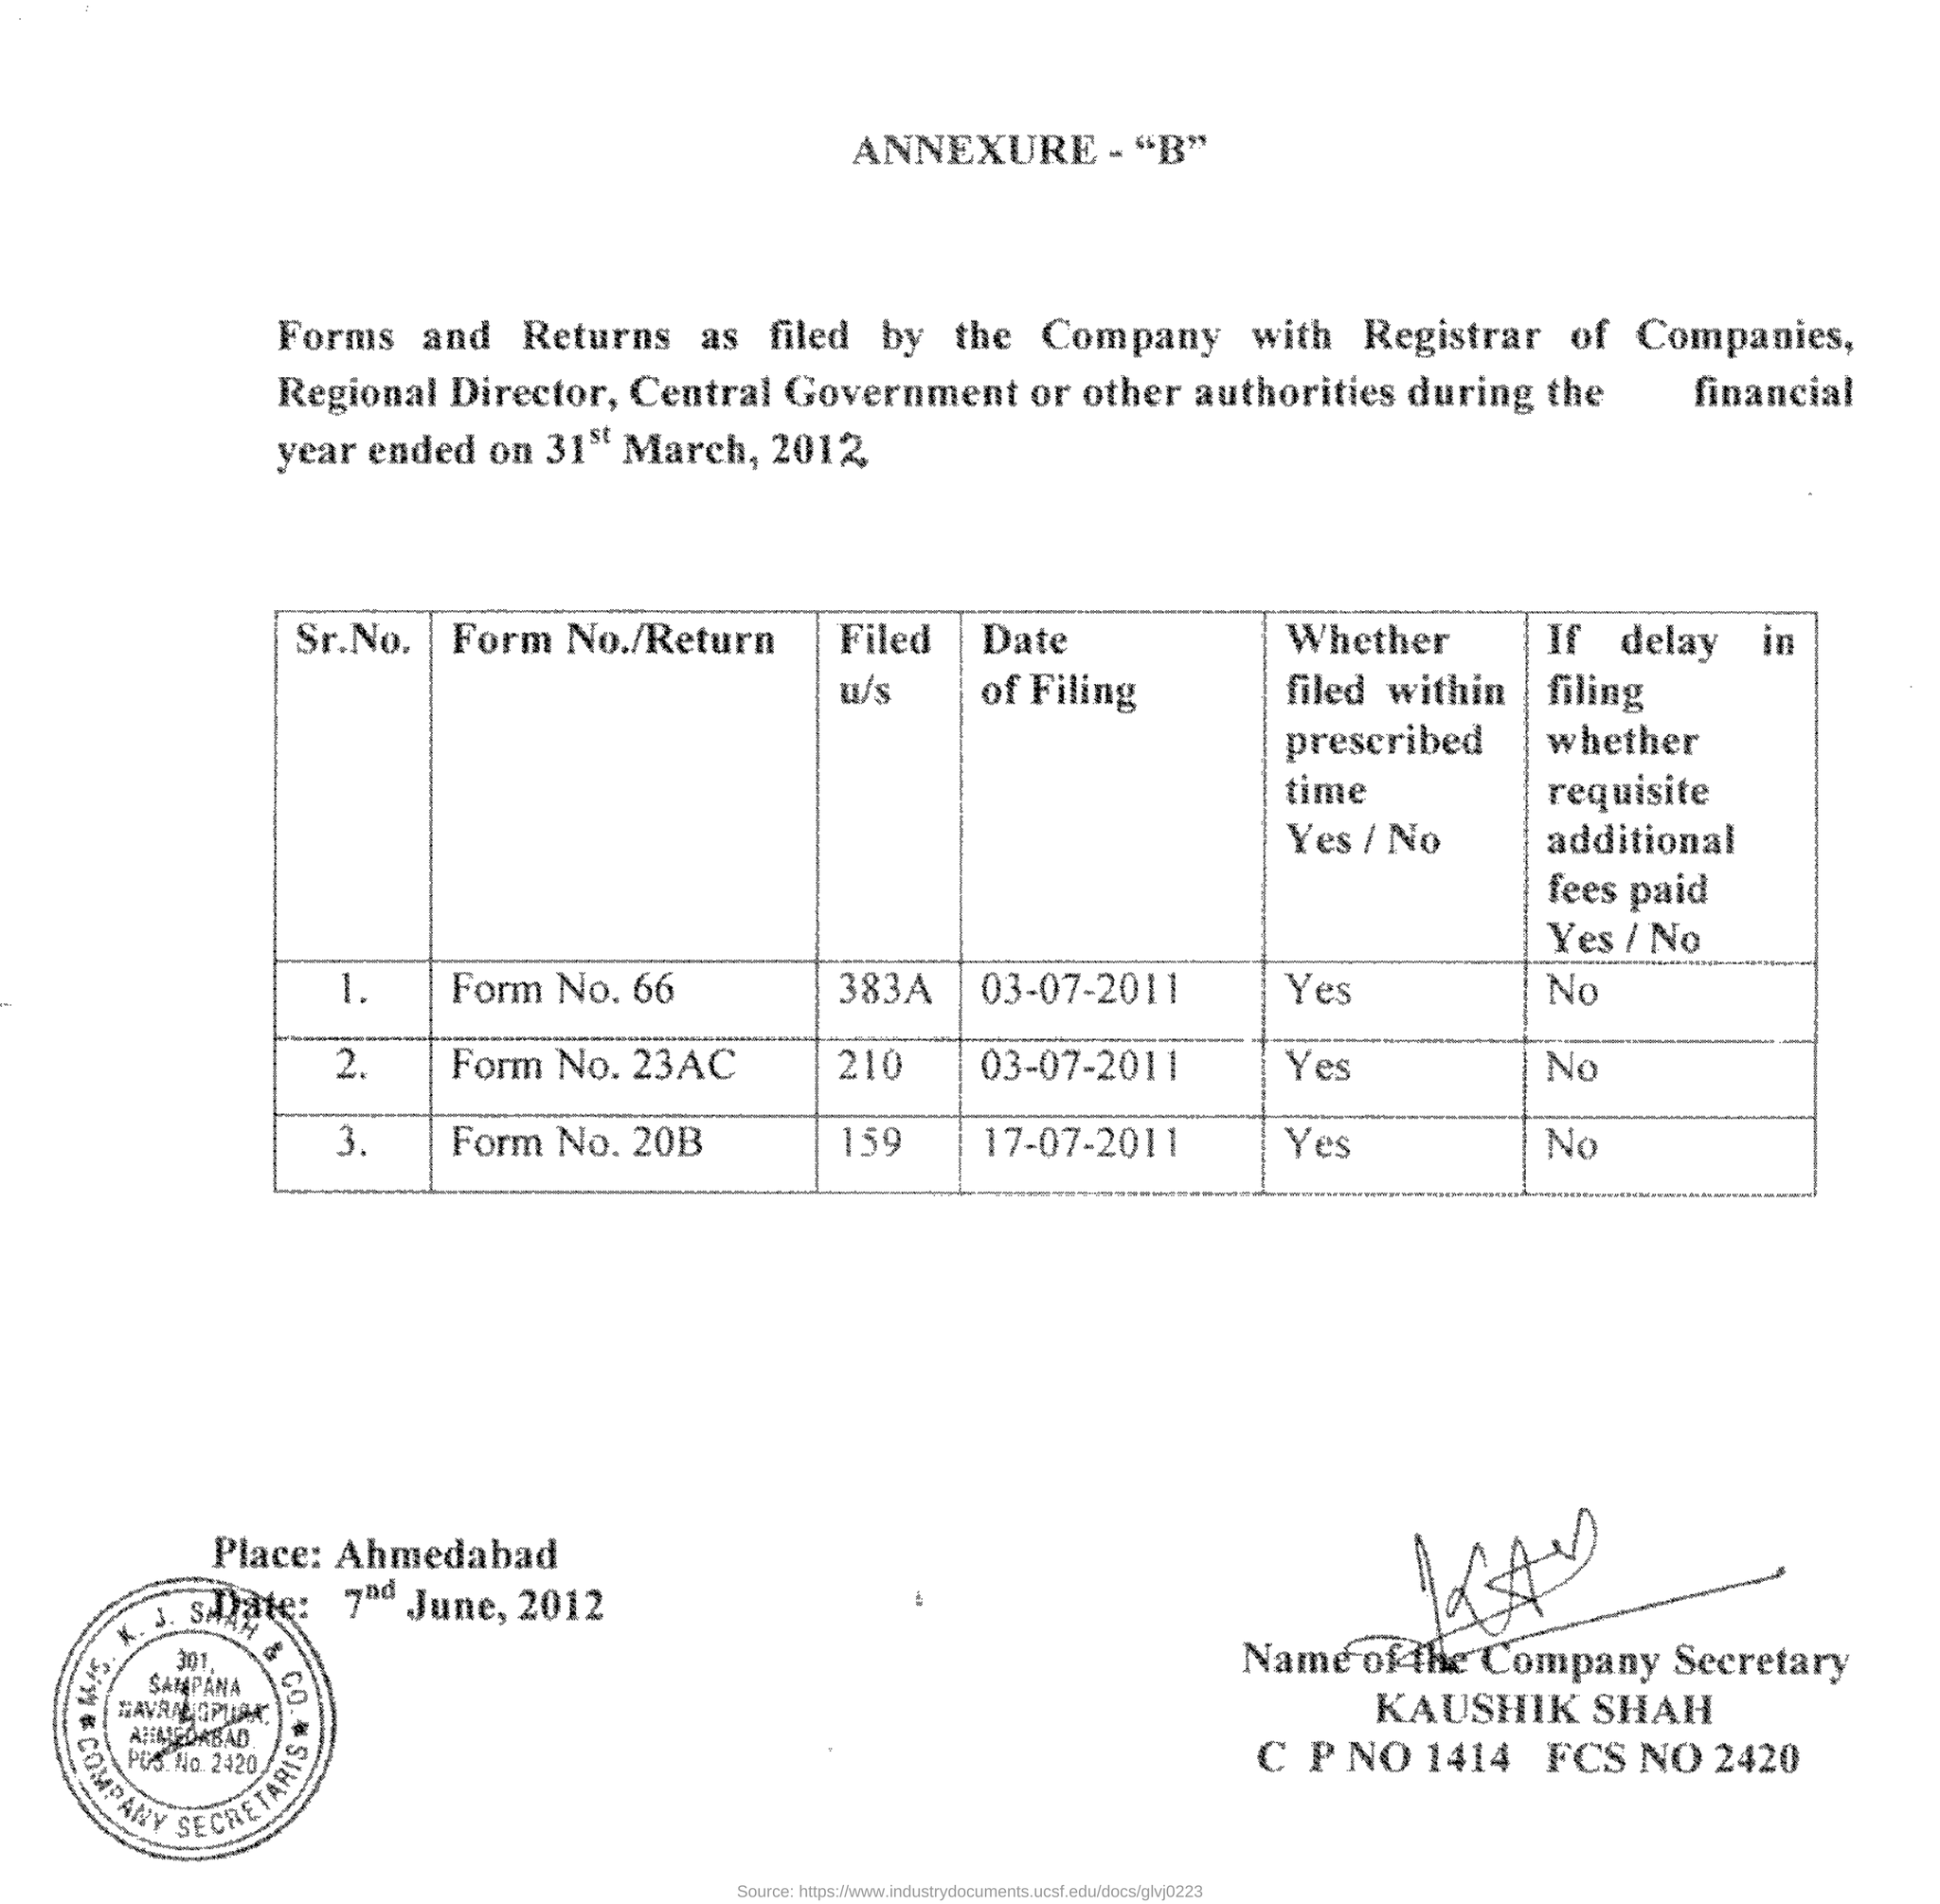What is the date of filing of form no.66
Offer a very short reply. 03-07-2011. Whether form no.20b filed within prescribed time?
Your answer should be very brief. Yes. What is the name of the company secretary?
Offer a terse response. KAUSHIk SHAH. 